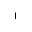<formula> <loc_0><loc_0><loc_500><loc_500>_ { 1 }</formula> 